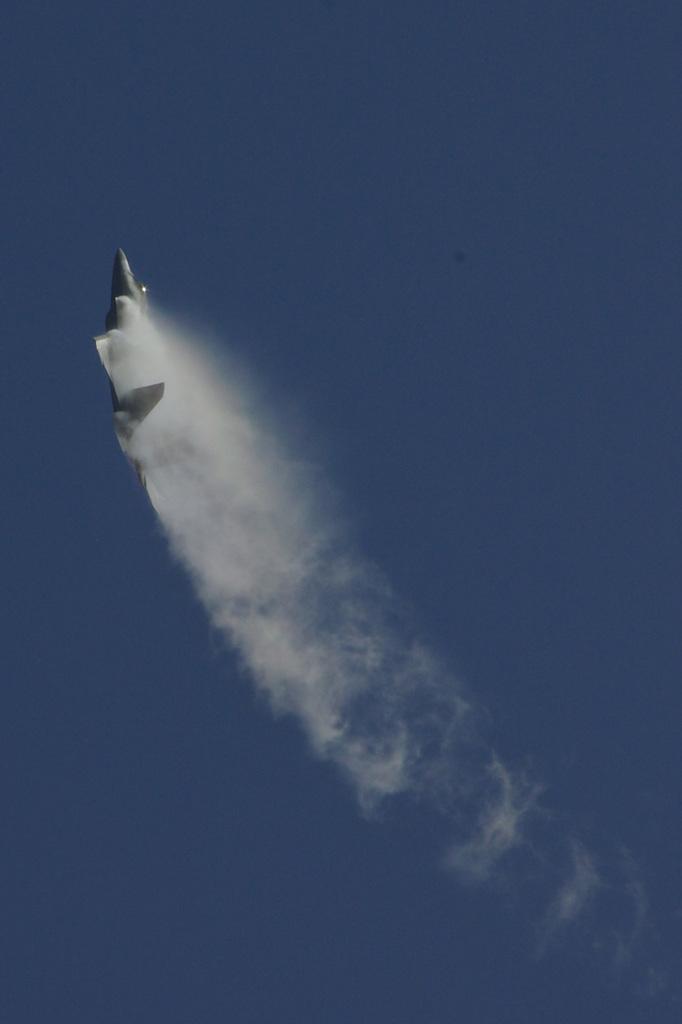In one or two sentences, can you explain what this image depicts? Here we can see an aeroplane flying in the sky. 